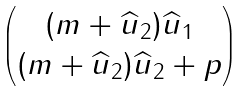<formula> <loc_0><loc_0><loc_500><loc_500>\begin{pmatrix} ( m + \widehat { u } _ { 2 } ) \widehat { u } _ { 1 } \\ ( m + \widehat { u } _ { 2 } ) \widehat { u } _ { 2 } + p \end{pmatrix}</formula> 